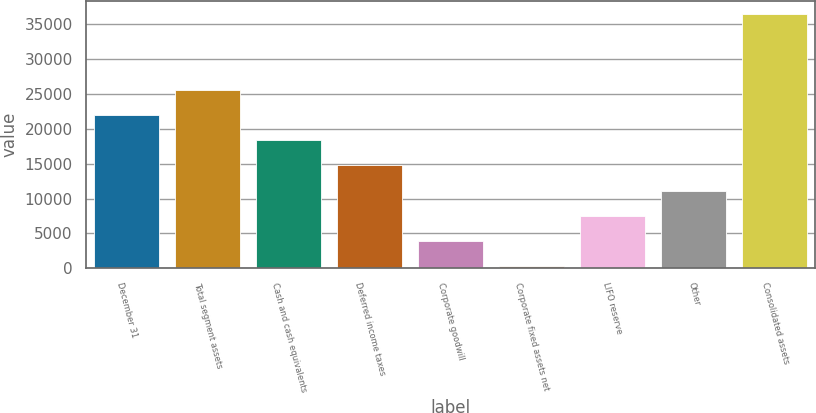<chart> <loc_0><loc_0><loc_500><loc_500><bar_chart><fcel>December 31<fcel>Total segment assets<fcel>Cash and cash equivalents<fcel>Deferred income taxes<fcel>Corporate goodwill<fcel>Corporate fixed assets net<fcel>LIFO reserve<fcel>Other<fcel>Consolidated assets<nl><fcel>21997.8<fcel>25617.6<fcel>18378<fcel>14758.2<fcel>3898.8<fcel>279<fcel>7518.6<fcel>11138.4<fcel>36477<nl></chart> 